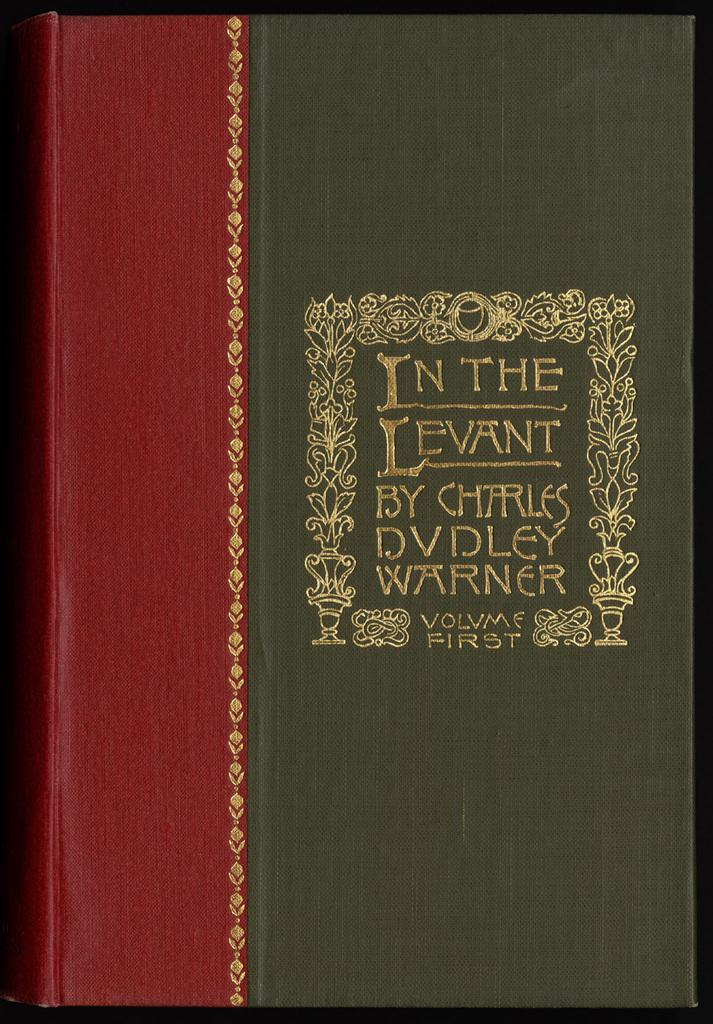<image>
Render a clear and concise summary of the photo. a close up of the book cover In The Levant by Charles Dudley Warner 